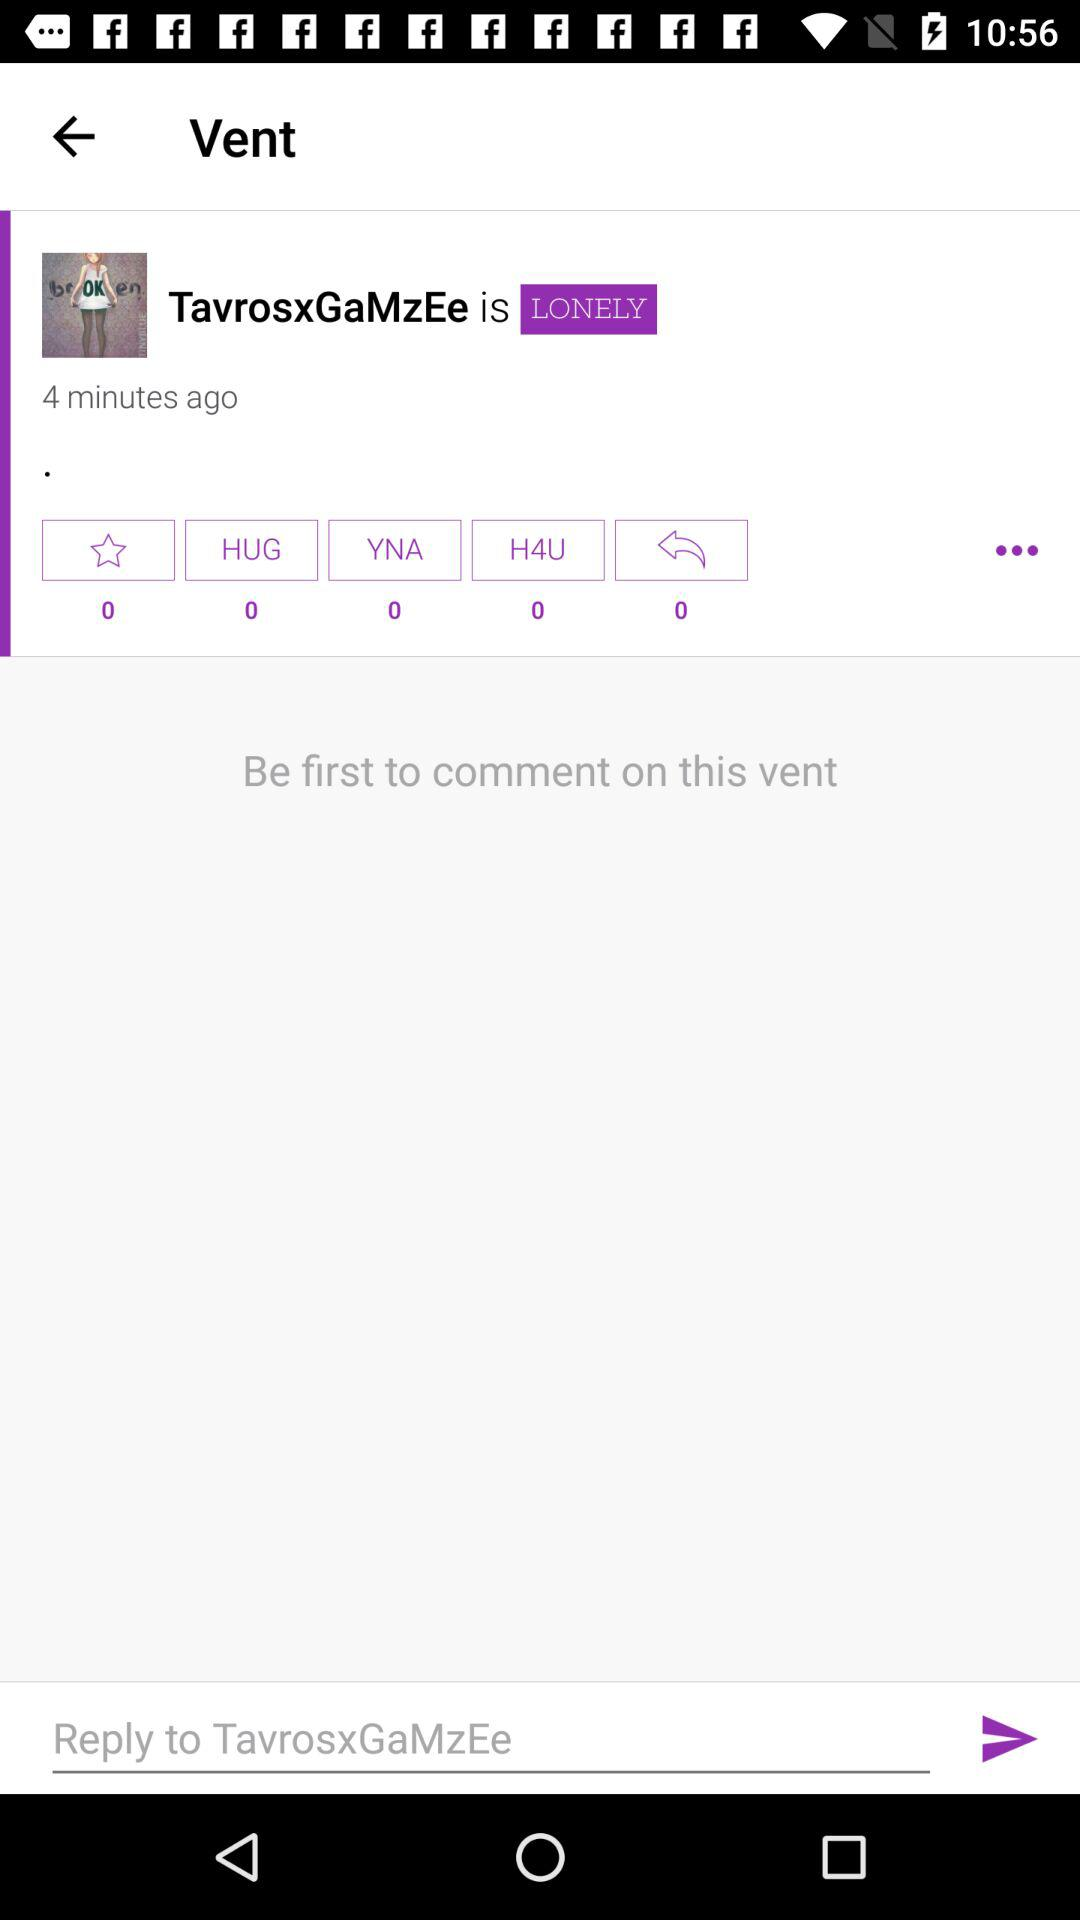What is the name of application?
When the provided information is insufficient, respond with <no answer>. <no answer> 